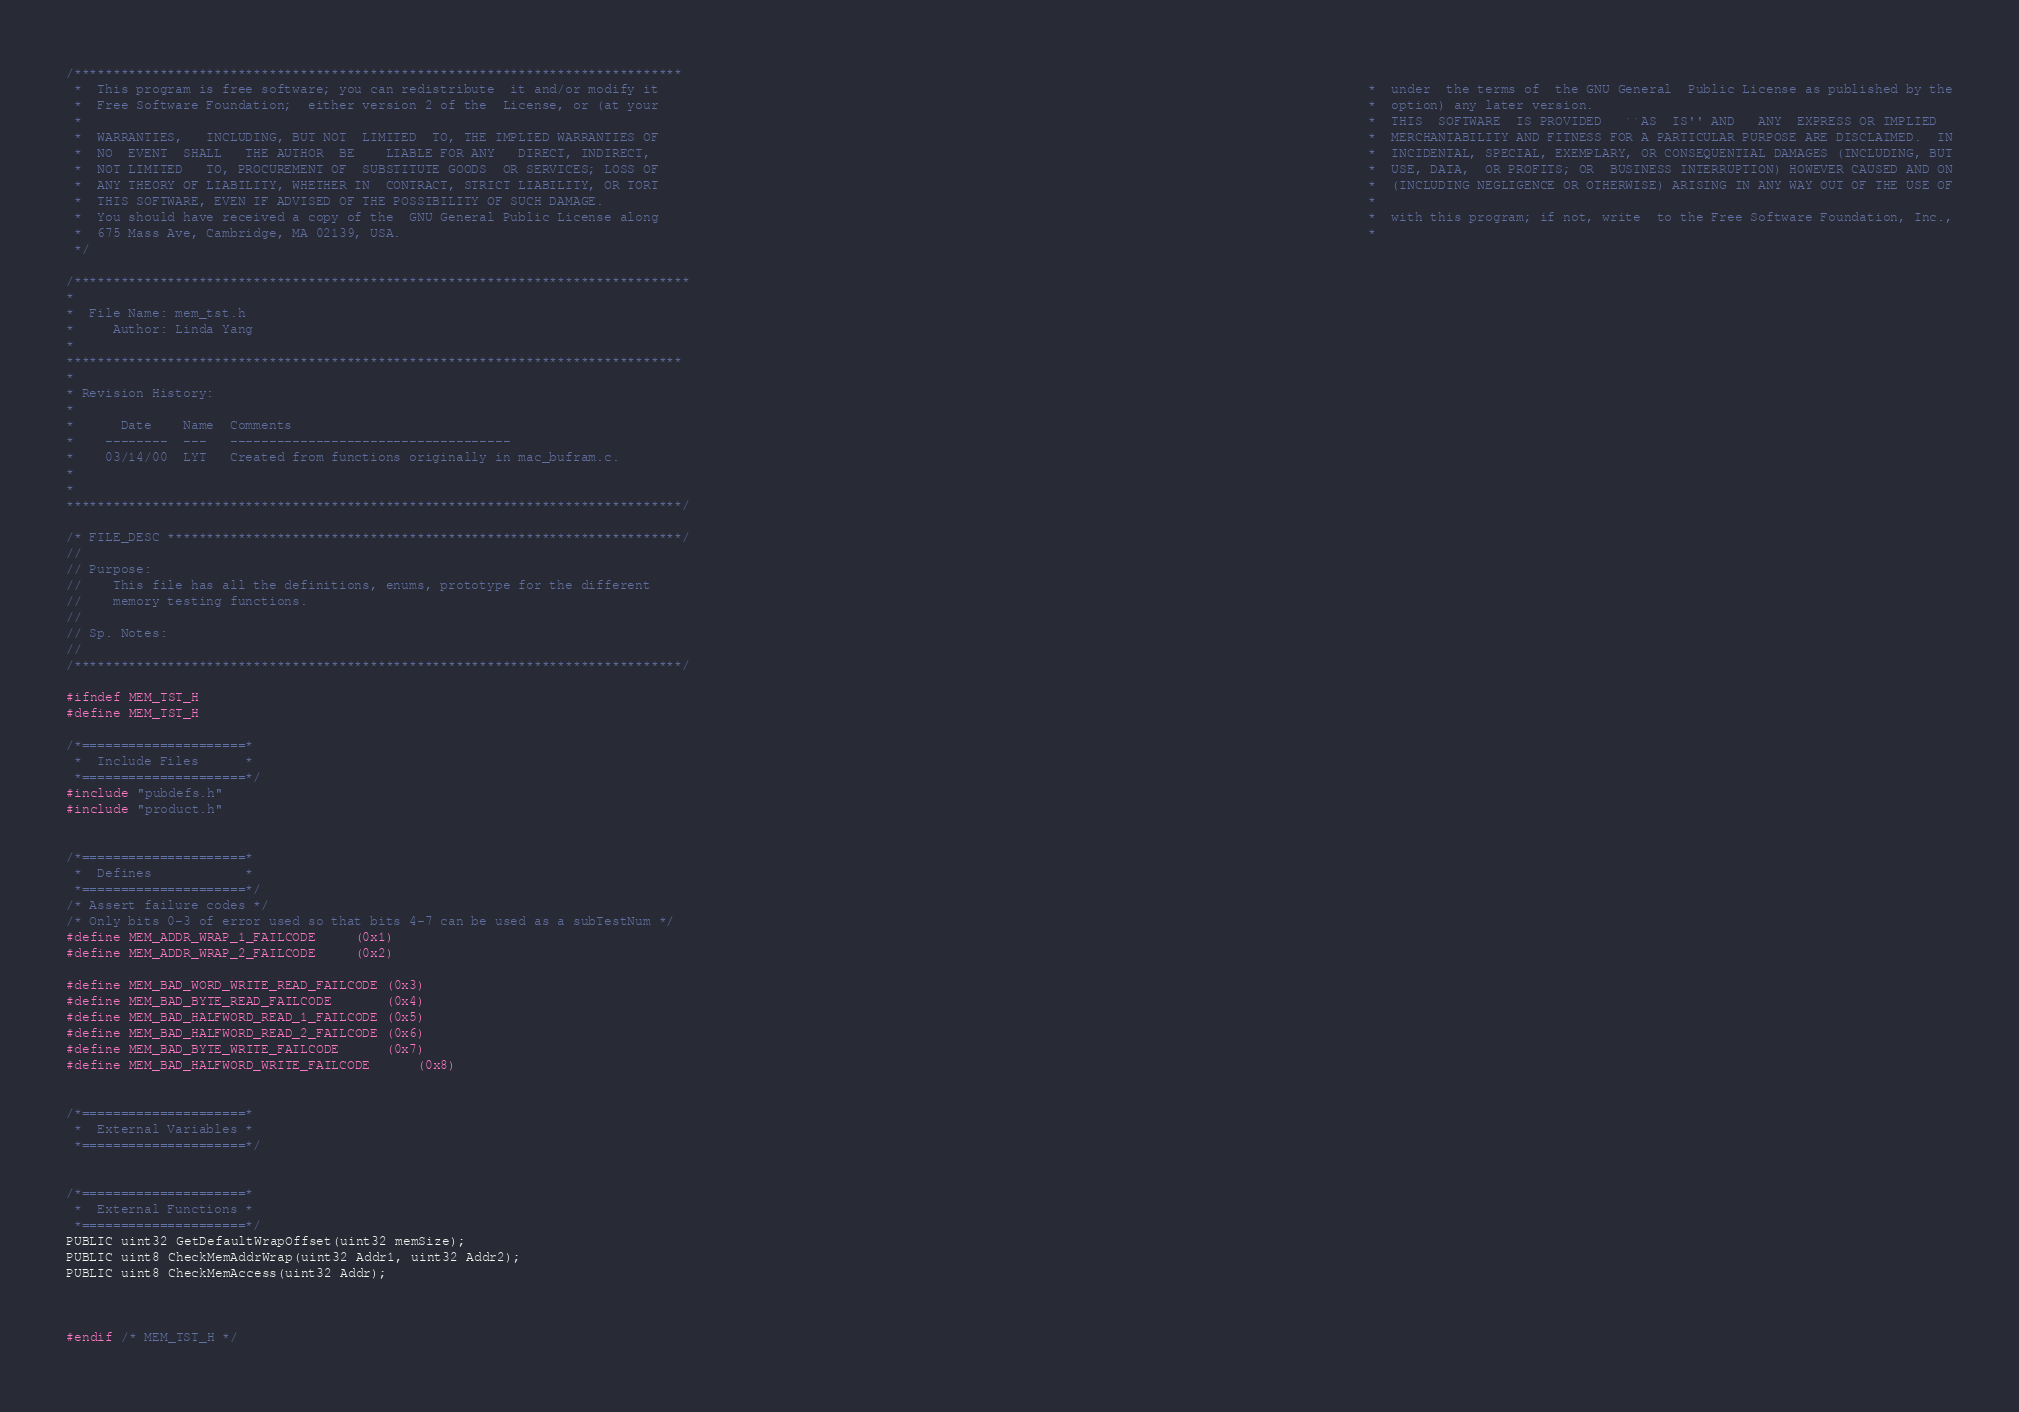<code> <loc_0><loc_0><loc_500><loc_500><_C_>/******************************************************************************
 *  This program is free software; you can redistribute  it and/or modify it                                                                                           *  under  the terms of  the GNU General  Public License as published by the
 *  Free Software Foundation;  either version 2 of the  License, or (at your                                                                                           *  option) any later version.
 *                                                                                                                                                                     *  THIS  SOFTWARE  IS PROVIDED   ``AS  IS'' AND   ANY  EXPRESS OR IMPLIED
 *  WARRANTIES,   INCLUDING, BUT NOT  LIMITED  TO, THE IMPLIED WARRANTIES OF                                                                                           *  MERCHANTABILITY AND FITNESS FOR A PARTICULAR PURPOSE ARE DISCLAIMED.  IN
 *  NO  EVENT  SHALL   THE AUTHOR  BE    LIABLE FOR ANY   DIRECT, INDIRECT,                                                                                            *  INCIDENTAL, SPECIAL, EXEMPLARY, OR CONSEQUENTIAL DAMAGES (INCLUDING, BUT
 *  NOT LIMITED   TO, PROCUREMENT OF  SUBSTITUTE GOODS  OR SERVICES; LOSS OF                                                                                           *  USE, DATA,  OR PROFITS; OR  BUSINESS INTERRUPTION) HOWEVER CAUSED AND ON
 *  ANY THEORY OF LIABILITY, WHETHER IN  CONTRACT, STRICT LIABILITY, OR TORT                                                                                           *  (INCLUDING NEGLIGENCE OR OTHERWISE) ARISING IN ANY WAY OUT OF THE USE OF
 *  THIS SOFTWARE, EVEN IF ADVISED OF THE POSSIBILITY OF SUCH DAMAGE.                                                                                                  *
 *  You should have received a copy of the  GNU General Public License along                                                                                           *  with this program; if not, write  to the Free Software Foundation, Inc.,
 *  675 Mass Ave, Cambridge, MA 02139, USA.                                                                                                                            *
 */

/*******************************************************************************
*
*  File Name: mem_tst.h
*     Author: Linda Yang
*
*******************************************************************************
*
* Revision History:
*
*      Date    Name  Comments
*    --------  ---   ------------------------------------
*    03/14/00  LYT   Created from functions originally in mac_bufram.c.
*
*
*******************************************************************************/

/* FILE_DESC ******************************************************************/
//
// Purpose:
//    This file has all the definitions, enums, prototype for the different 
//    memory testing functions. 
//
// Sp. Notes:
//
/******************************************************************************/

#ifndef MEM_TST_H
#define MEM_TST_H

/*=====================*
 *  Include Files      *
 *=====================*/
#include "pubdefs.h"
#include "product.h"


/*=====================*
 *  Defines            *
 *=====================*/
/* Assert failure codes */
/* Only bits 0-3 of error used so that bits 4-7 can be used as a subTestNum */
#define MEM_ADDR_WRAP_1_FAILCODE		(0x1)
#define MEM_ADDR_WRAP_2_FAILCODE		(0x2)

#define MEM_BAD_WORD_WRITE_READ_FAILCODE	(0x3)
#define MEM_BAD_BYTE_READ_FAILCODE		(0x4)
#define MEM_BAD_HALFWORD_READ_1_FAILCODE	(0x5)
#define MEM_BAD_HALFWORD_READ_2_FAILCODE	(0x6)
#define MEM_BAD_BYTE_WRITE_FAILCODE		(0x7)
#define MEM_BAD_HALFWORD_WRITE_FAILCODE		(0x8)


/*=====================*
 *  External Variables *
 *=====================*/


/*=====================*
 *  External Functions *
 *=====================*/
PUBLIC uint32 GetDefaultWrapOffset(uint32 memSize);
PUBLIC uint8 CheckMemAddrWrap(uint32 Addr1, uint32 Addr2);
PUBLIC uint8 CheckMemAccess(uint32 Addr);



#endif /* MEM_TST_H */
</code> 